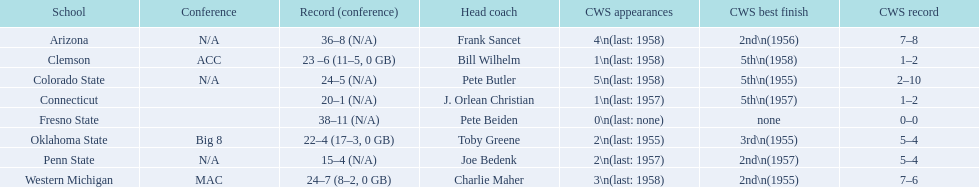What are each of the educational facilities? Arizona, Clemson, Colorado State, Connecticut, Fresno State, Oklahoma State, Penn State, Western Michigan. Could you help me parse every detail presented in this table? {'header': ['School', 'Conference', 'Record (conference)', 'Head coach', 'CWS appearances', 'CWS best finish', 'CWS record'], 'rows': [['Arizona', 'N/A', '36–8 (N/A)', 'Frank Sancet', '4\\n(last: 1958)', '2nd\\n(1956)', '7–8'], ['Clemson', 'ACC', '23 –6 (11–5, 0 GB)', 'Bill Wilhelm', '1\\n(last: 1958)', '5th\\n(1958)', '1–2'], ['Colorado State', 'N/A', '24–5 (N/A)', 'Pete Butler', '5\\n(last: 1958)', '5th\\n(1955)', '2–10'], ['Connecticut', '', '20–1 (N/A)', 'J. Orlean Christian', '1\\n(last: 1957)', '5th\\n(1957)', '1–2'], ['Fresno State', '', '38–11 (N/A)', 'Pete Beiden', '0\\n(last: none)', 'none', '0–0'], ['Oklahoma State', 'Big 8', '22–4 (17–3, 0 GB)', 'Toby Greene', '2\\n(last: 1955)', '3rd\\n(1955)', '5–4'], ['Penn State', 'N/A', '15–4 (N/A)', 'Joe Bedenk', '2\\n(last: 1957)', '2nd\\n(1957)', '5–4'], ['Western Michigan', 'MAC', '24–7 (8–2, 0 GB)', 'Charlie Maher', '3\\n(last: 1958)', '2nd\\n(1955)', '7–6']]} Which team had under 20 wins? Penn State. 